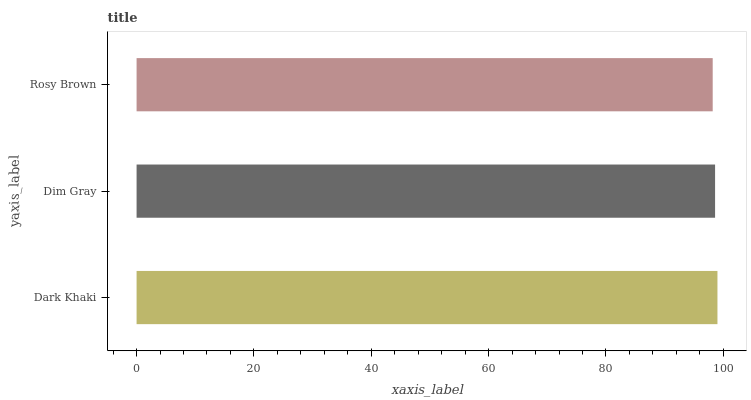Is Rosy Brown the minimum?
Answer yes or no. Yes. Is Dark Khaki the maximum?
Answer yes or no. Yes. Is Dim Gray the minimum?
Answer yes or no. No. Is Dim Gray the maximum?
Answer yes or no. No. Is Dark Khaki greater than Dim Gray?
Answer yes or no. Yes. Is Dim Gray less than Dark Khaki?
Answer yes or no. Yes. Is Dim Gray greater than Dark Khaki?
Answer yes or no. No. Is Dark Khaki less than Dim Gray?
Answer yes or no. No. Is Dim Gray the high median?
Answer yes or no. Yes. Is Dim Gray the low median?
Answer yes or no. Yes. Is Rosy Brown the high median?
Answer yes or no. No. Is Dark Khaki the low median?
Answer yes or no. No. 